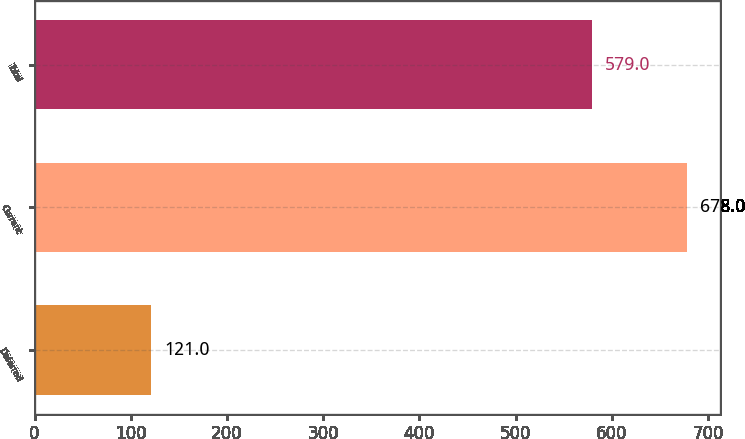Convert chart to OTSL. <chart><loc_0><loc_0><loc_500><loc_500><bar_chart><fcel>Deferred<fcel>Current<fcel>Total<nl><fcel>121<fcel>678<fcel>579<nl></chart> 